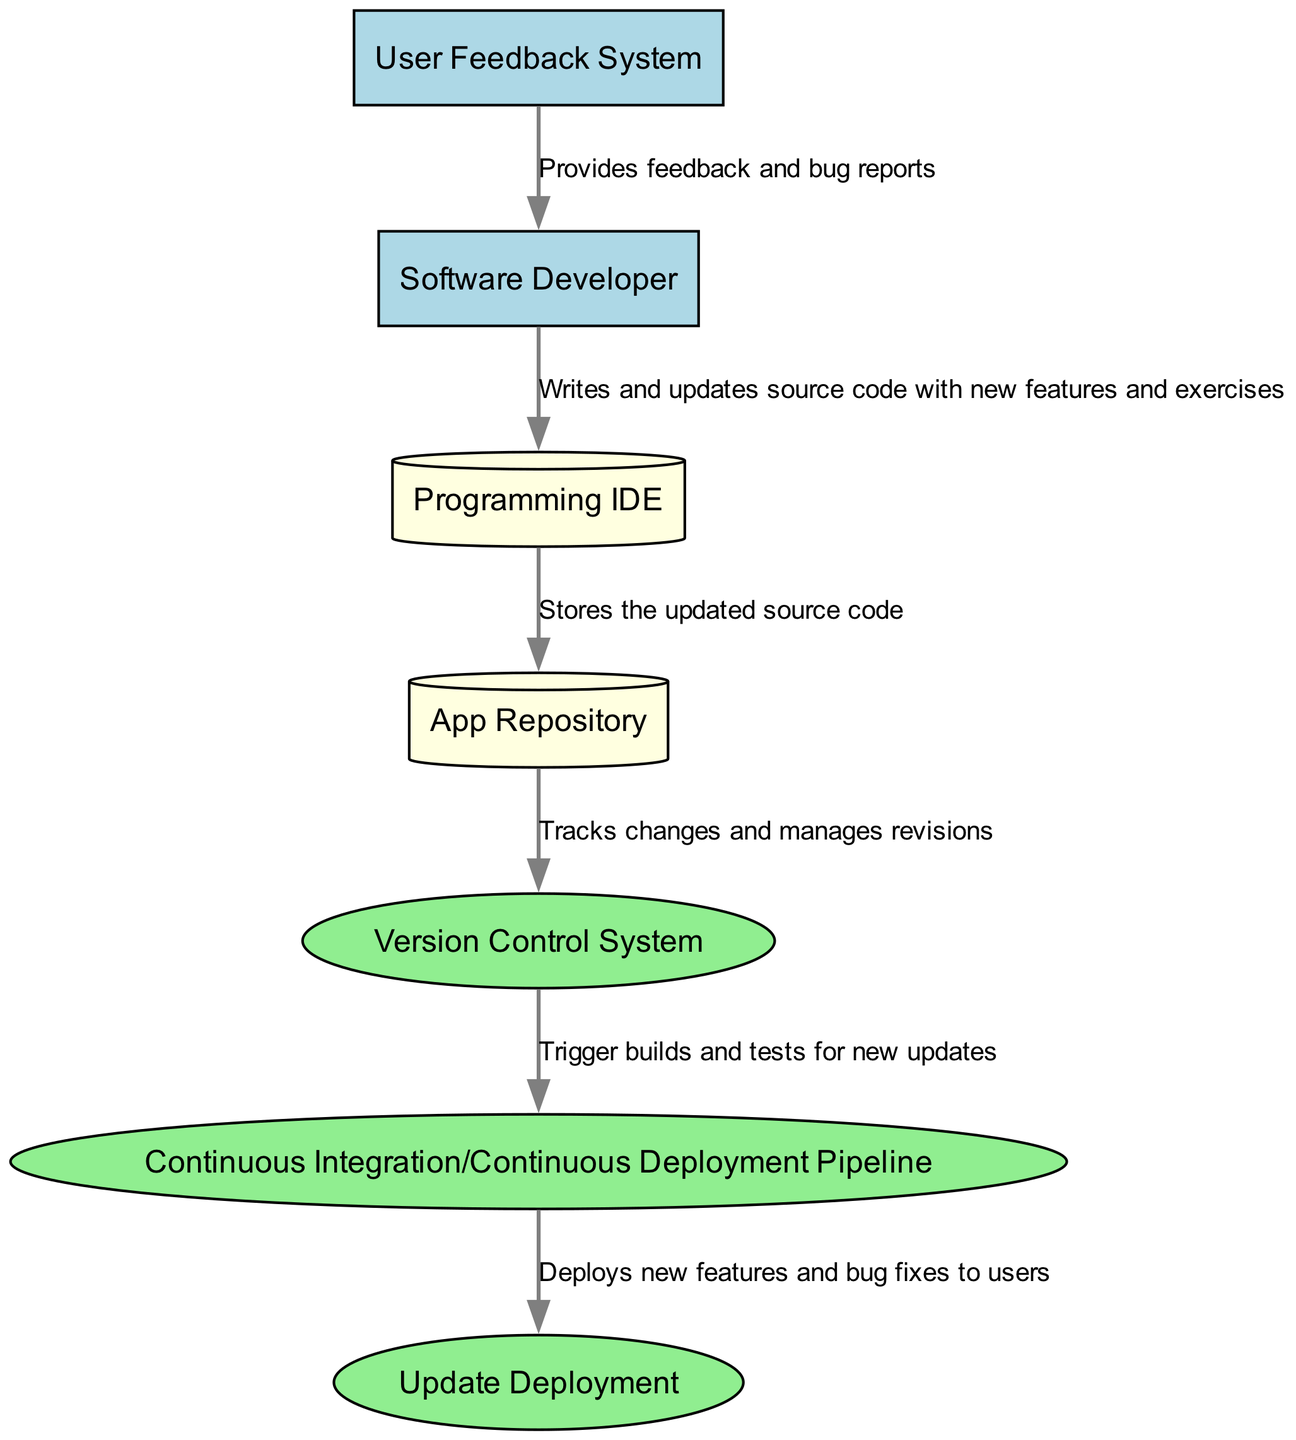what is the total number of entities in the diagram? The diagram contains a total of 6 entities: 1 Software Developer, 1 App Repository, 1 Version Control System, 1 Programming IDE, 1 User Feedback System, and 1 Continuous Integration/Continuous Deployment Pipeline. Therefore, the count of entities is 6.
Answer: 6 what process manages changes to the app's source code? The process that specifically manages changes to the app's source code in the diagram is labeled "Version Control System." This indicates its role in tracking revisions and facilitating collaboration.
Answer: Version Control System which external entity provides feedback to the software developer? The external entity that provides user feedback in the diagram is the "User Feedback System." It forwards the users' feedback and bug reports to the software developer.
Answer: User Feedback System what is the flow of information from the Programming IDE to the App Repository? The flow of information from the Programming IDE to the App Repository is specifically described as "Stores the updated source code." This means that any source code written and updated in the Programming IDE is sent here for storage.
Answer: Stores the updated source code how many processes are responsible for deployment in the diagram? There are two processes that deal with deployment in the diagram: "Update Deployment" and "Continuous Integration/Continuous Deployment Pipeline." These processes handle the delivery and surgical deployment of new features and bug fixes for users.
Answer: 2 